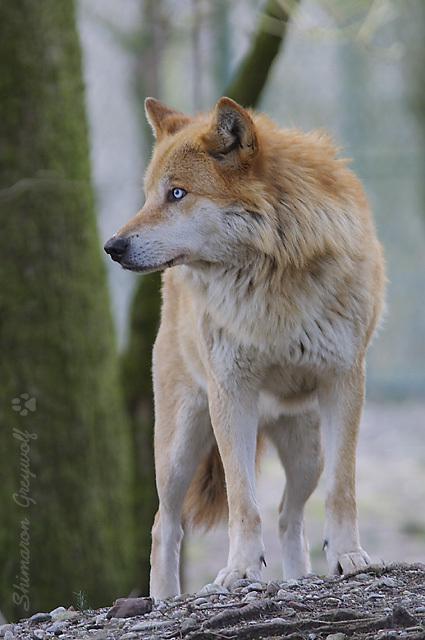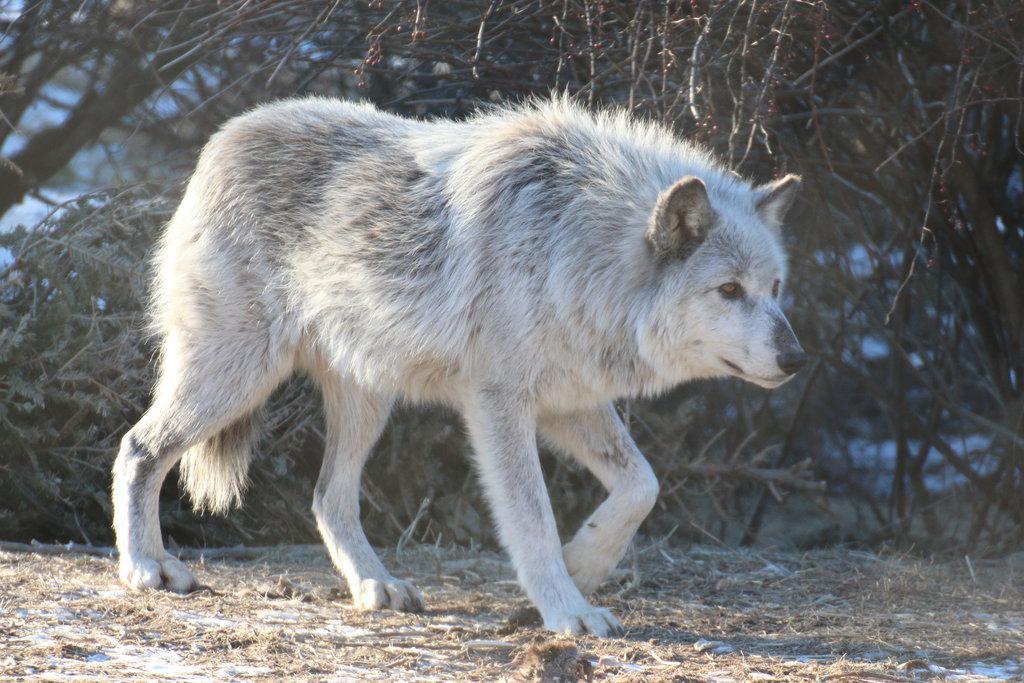The first image is the image on the left, the second image is the image on the right. For the images displayed, is the sentence "An image shows a standing wolf facing the camera." factually correct? Answer yes or no. No. The first image is the image on the left, the second image is the image on the right. Examine the images to the left and right. Is the description "The animal in the image on the right is looking toward the camera" accurate? Answer yes or no. No. 